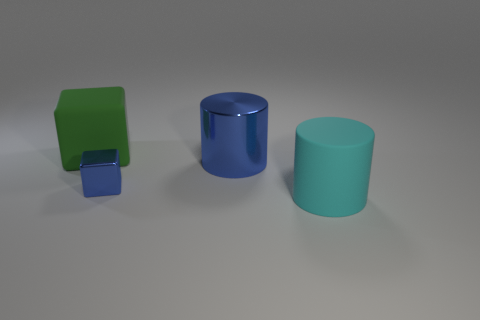Add 1 big cyan objects. How many objects exist? 5 Subtract all gray cubes. How many cyan cylinders are left? 1 Subtract 0 red spheres. How many objects are left? 4 Subtract 1 cylinders. How many cylinders are left? 1 Subtract all green blocks. Subtract all purple cylinders. How many blocks are left? 1 Subtract all gray shiny objects. Subtract all cyan cylinders. How many objects are left? 3 Add 1 blue cubes. How many blue cubes are left? 2 Add 4 big green objects. How many big green objects exist? 5 